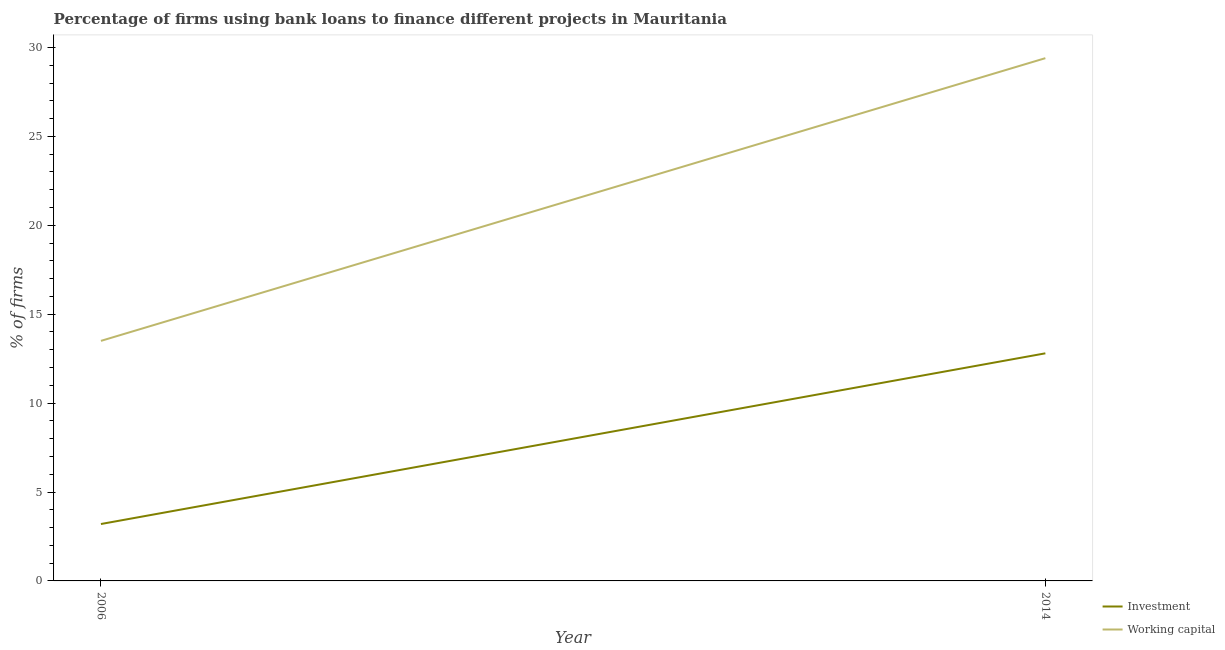How many different coloured lines are there?
Ensure brevity in your answer.  2. Does the line corresponding to percentage of firms using banks to finance investment intersect with the line corresponding to percentage of firms using banks to finance working capital?
Offer a terse response. No. What is the percentage of firms using banks to finance working capital in 2014?
Offer a very short reply. 29.4. Across all years, what is the maximum percentage of firms using banks to finance working capital?
Ensure brevity in your answer.  29.4. Across all years, what is the minimum percentage of firms using banks to finance investment?
Ensure brevity in your answer.  3.2. In which year was the percentage of firms using banks to finance working capital maximum?
Offer a terse response. 2014. What is the total percentage of firms using banks to finance working capital in the graph?
Ensure brevity in your answer.  42.9. What is the difference between the percentage of firms using banks to finance working capital in 2006 and that in 2014?
Offer a very short reply. -15.9. What is the difference between the percentage of firms using banks to finance working capital in 2006 and the percentage of firms using banks to finance investment in 2014?
Your response must be concise. 0.7. What is the average percentage of firms using banks to finance working capital per year?
Make the answer very short. 21.45. Is the percentage of firms using banks to finance working capital in 2006 less than that in 2014?
Keep it short and to the point. Yes. In how many years, is the percentage of firms using banks to finance working capital greater than the average percentage of firms using banks to finance working capital taken over all years?
Offer a terse response. 1. Are the values on the major ticks of Y-axis written in scientific E-notation?
Keep it short and to the point. No. Does the graph contain grids?
Your answer should be very brief. No. How are the legend labels stacked?
Keep it short and to the point. Vertical. What is the title of the graph?
Provide a short and direct response. Percentage of firms using bank loans to finance different projects in Mauritania. Does "Death rate" appear as one of the legend labels in the graph?
Make the answer very short. No. What is the label or title of the X-axis?
Provide a short and direct response. Year. What is the label or title of the Y-axis?
Provide a succinct answer. % of firms. What is the % of firms in Investment in 2006?
Your answer should be compact. 3.2. What is the % of firms of Working capital in 2014?
Your answer should be compact. 29.4. Across all years, what is the maximum % of firms of Working capital?
Your response must be concise. 29.4. Across all years, what is the minimum % of firms in Investment?
Ensure brevity in your answer.  3.2. Across all years, what is the minimum % of firms of Working capital?
Provide a succinct answer. 13.5. What is the total % of firms of Working capital in the graph?
Your response must be concise. 42.9. What is the difference between the % of firms in Working capital in 2006 and that in 2014?
Ensure brevity in your answer.  -15.9. What is the difference between the % of firms of Investment in 2006 and the % of firms of Working capital in 2014?
Offer a very short reply. -26.2. What is the average % of firms in Working capital per year?
Make the answer very short. 21.45. In the year 2006, what is the difference between the % of firms in Investment and % of firms in Working capital?
Make the answer very short. -10.3. In the year 2014, what is the difference between the % of firms in Investment and % of firms in Working capital?
Ensure brevity in your answer.  -16.6. What is the ratio of the % of firms in Working capital in 2006 to that in 2014?
Provide a short and direct response. 0.46. What is the difference between the highest and the second highest % of firms of Investment?
Give a very brief answer. 9.6. What is the difference between the highest and the lowest % of firms of Investment?
Provide a succinct answer. 9.6. What is the difference between the highest and the lowest % of firms in Working capital?
Your response must be concise. 15.9. 